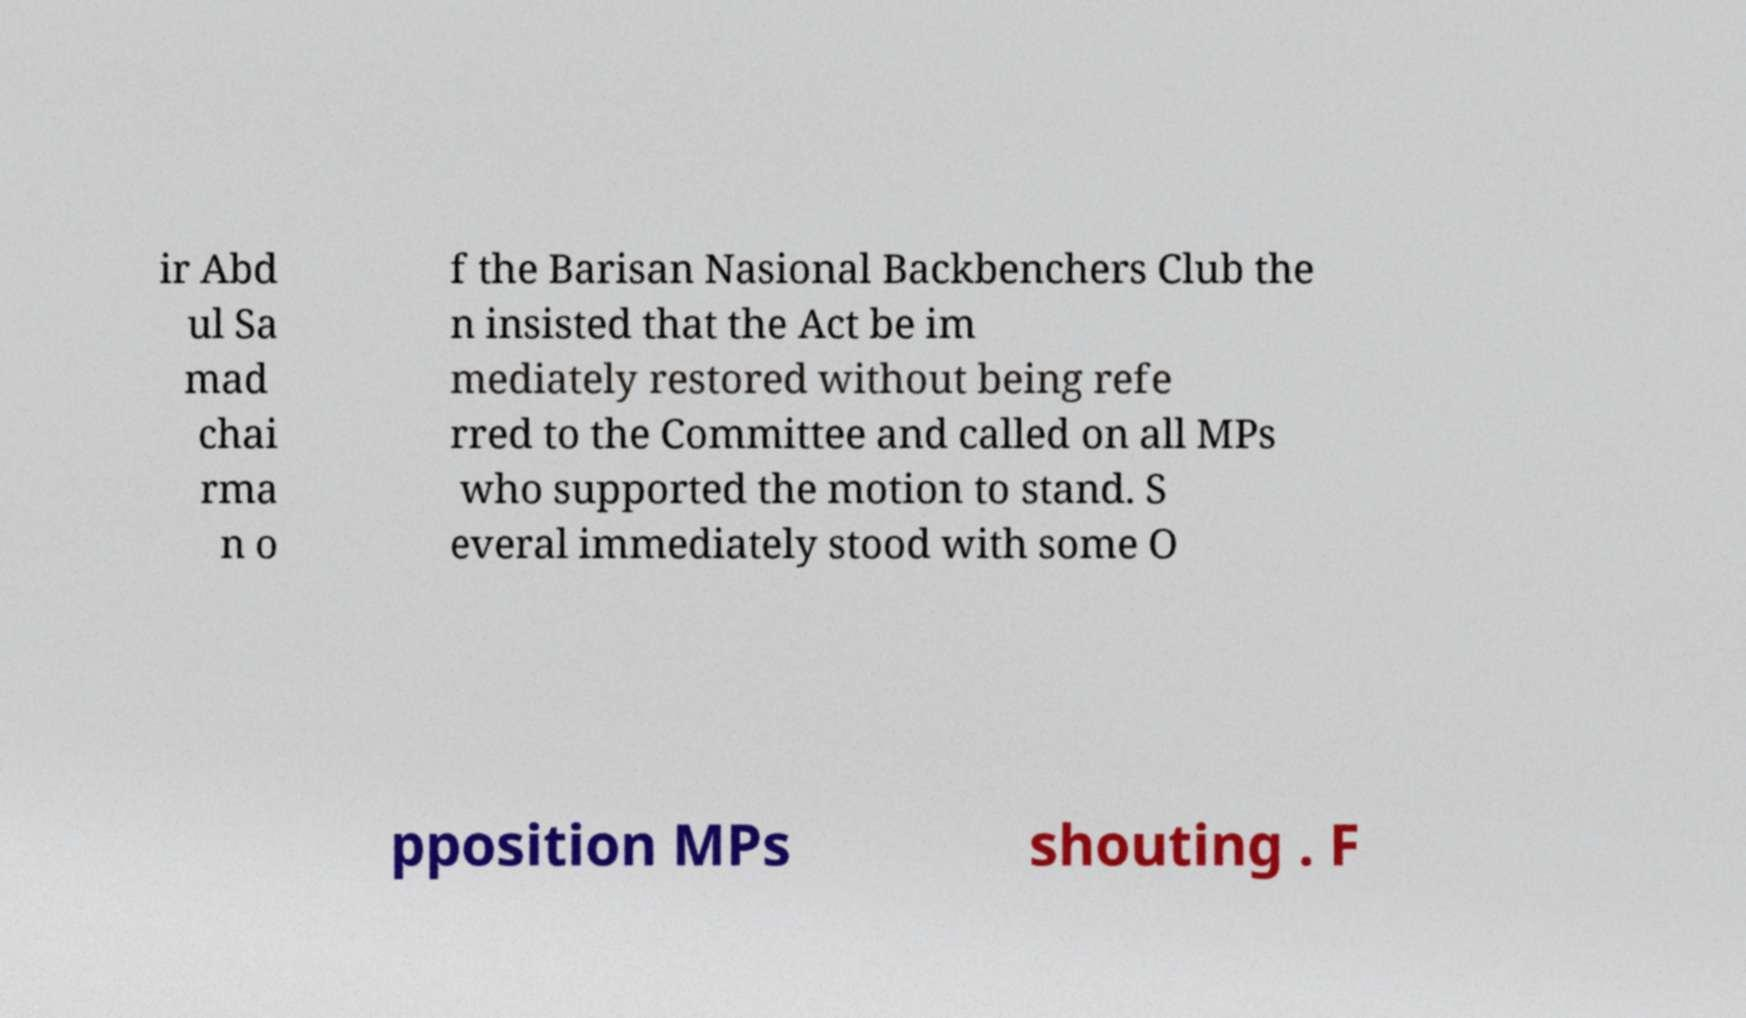Can you read and provide the text displayed in the image?This photo seems to have some interesting text. Can you extract and type it out for me? ir Abd ul Sa mad chai rma n o f the Barisan Nasional Backbenchers Club the n insisted that the Act be im mediately restored without being refe rred to the Committee and called on all MPs who supported the motion to stand. S everal immediately stood with some O pposition MPs shouting . F 